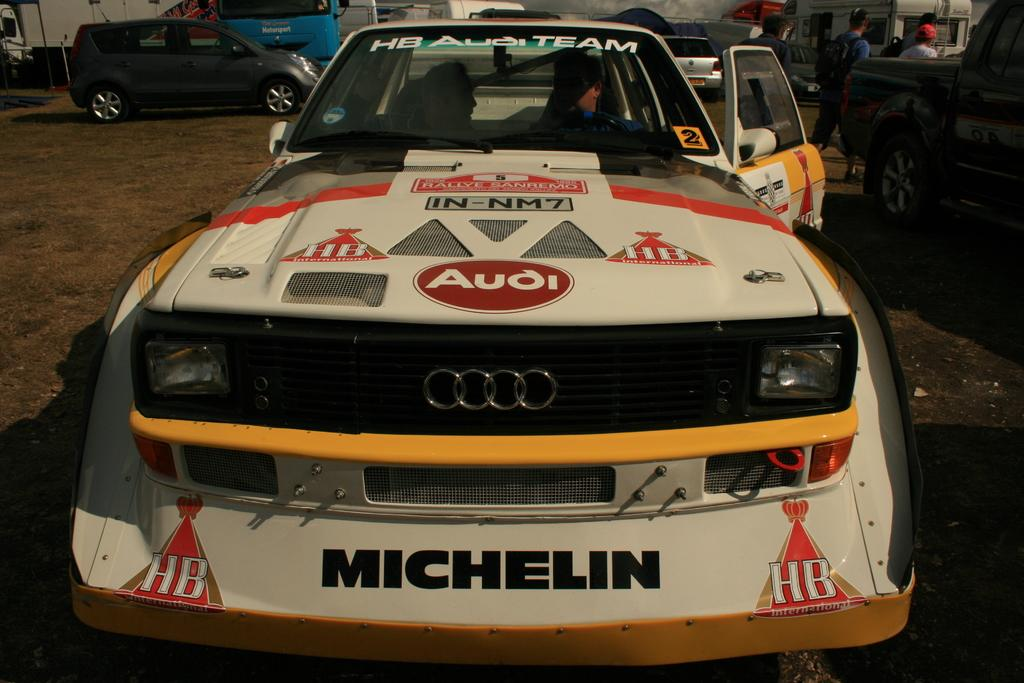<image>
Create a compact narrative representing the image presented. Race car sponsored by Michelin and is part of the HB Audi Team. 